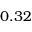<formula> <loc_0><loc_0><loc_500><loc_500>0 . 3 2</formula> 